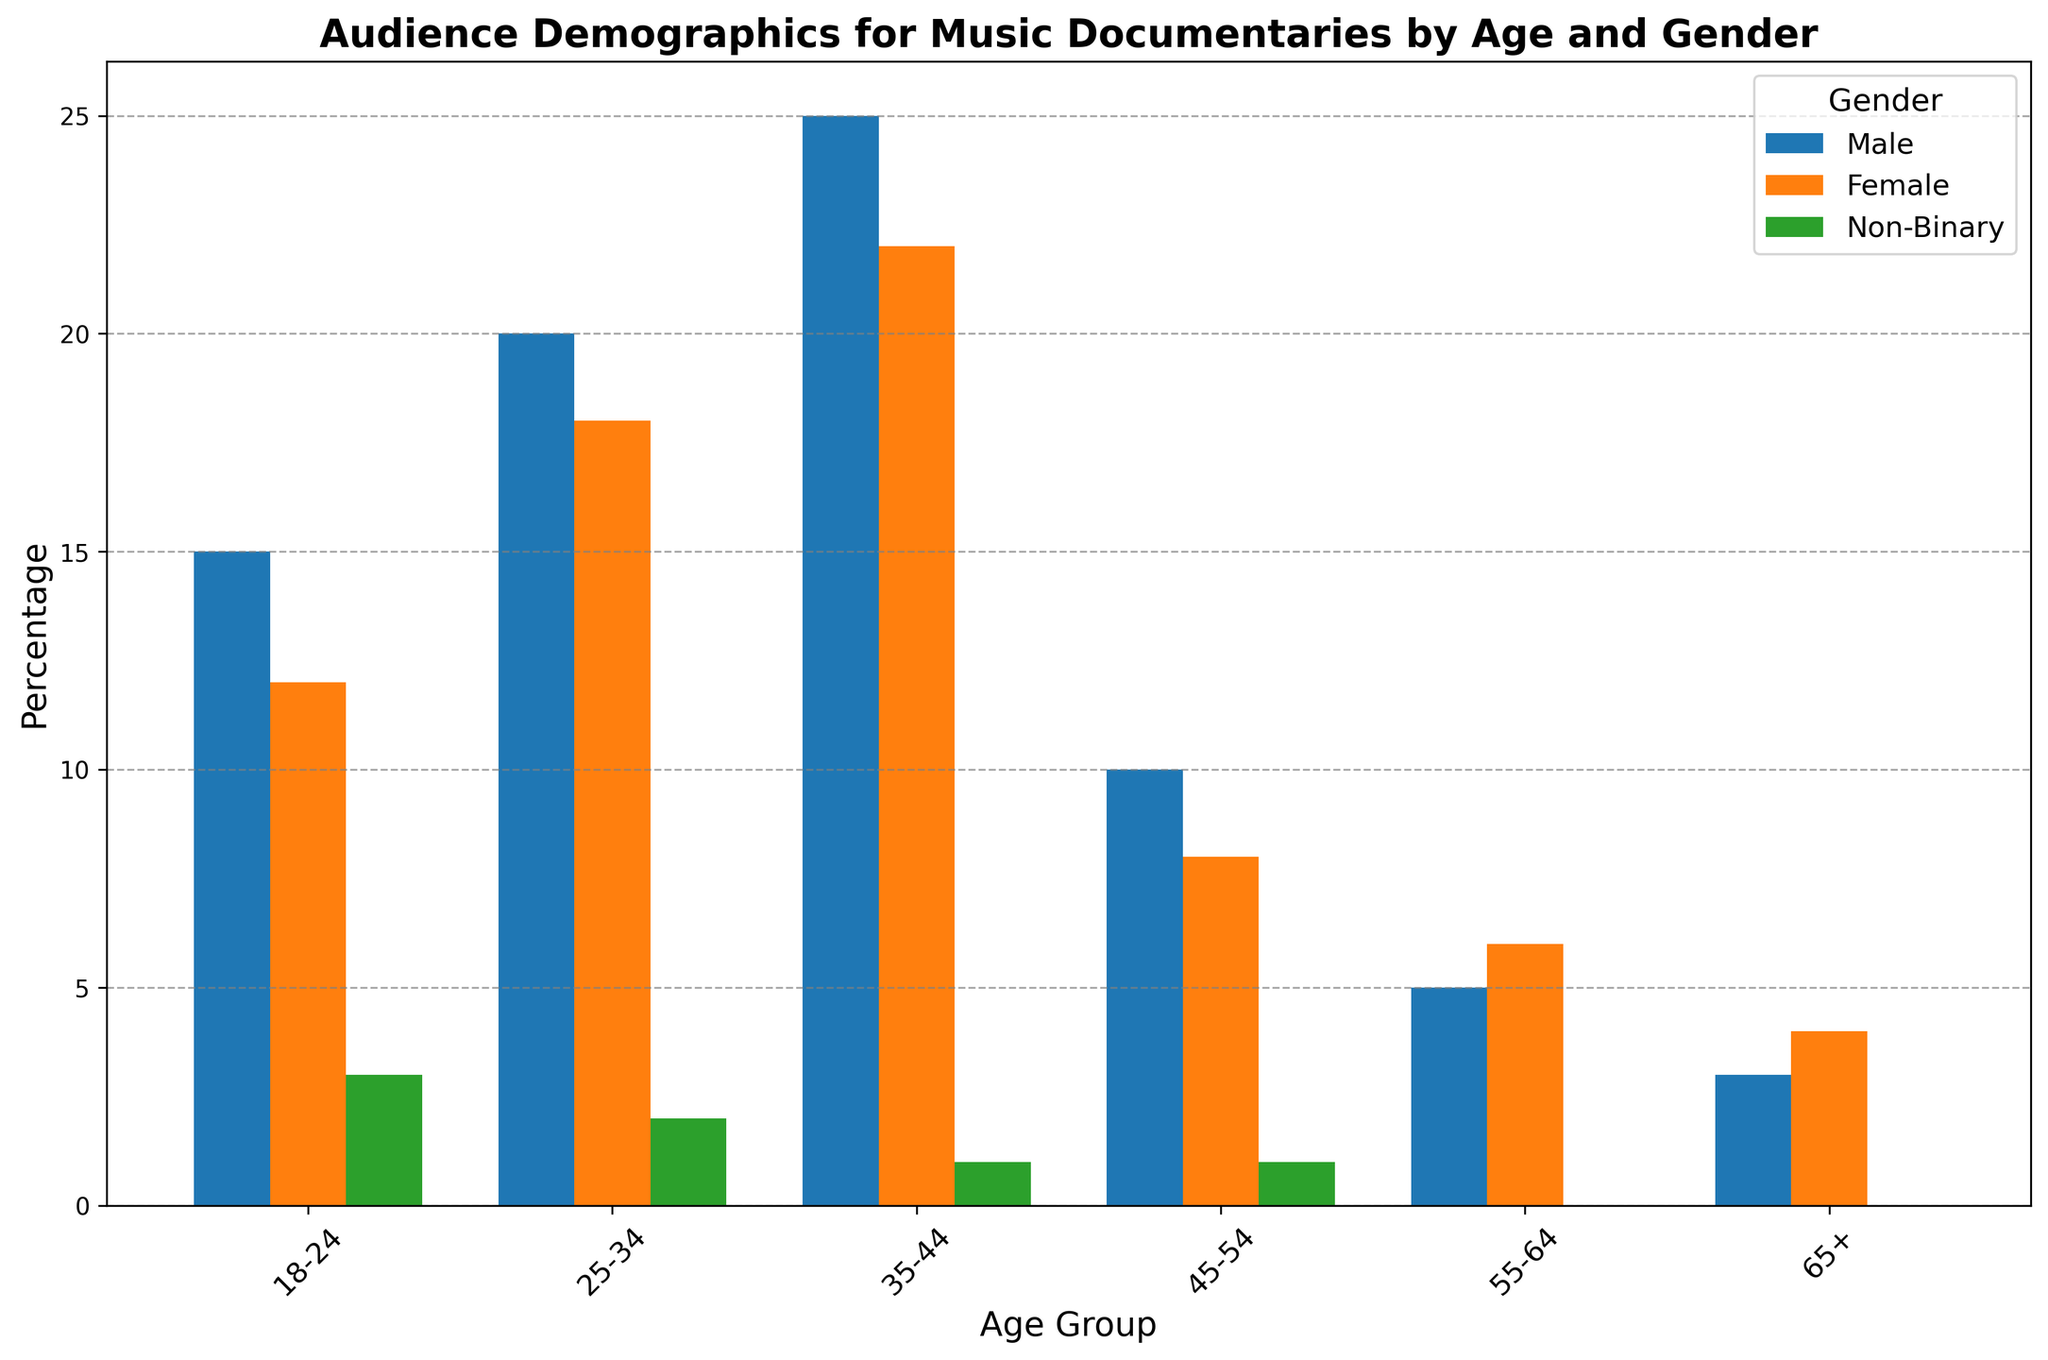Which gender has the highest percentage in the 35-44 age group? Look at the bars representing the 35-44 age group and compare the heights for each gender. The highest bar belongs to males.
Answer: Male What is the difference in percentage between males and females in the 25-34 age group? Find the heights of the bars for males and females in the 25-34 age group. Males have 20% and females have 18%. Subtract the female percentage from the male percentage: 20 - 18.
Answer: 2% Which age group has the lowest percentage of non-binary viewers? Look at all the bars representing non-binary viewers. The 55-64 and 65+ age groups both have the lowest bars, each showing 0%.
Answer: 55-64 and 65+ What is the total percentage of viewers aged 18-24? Sum the heights of the bars for males, females, and non-binary viewers in the 18-24 age group: 15 + 12 + 3.
Answer: 30% How many percentage points higher is the male percentage compared to the female percentage in the 35-44 age group? Compare the values for males and females in the 35-44 age group. Males have 25% and females have 22%. Subtract the female percentage from the male percentage: 25 - 22.
Answer: 3% In which age group do females have the highest percentage of viewers? Compare the heights of all the bars representing female viewers across different age groups. The highest bar for females is in the 35-44 age group.
Answer: 35-44 Is there an age group in which the percentage of non-binary viewers equals that of male viewers? Go through each age group and compare the heights of bars for non-binary and male viewers. There is no such age group where these percentages are equal.
Answer: No What is the average percentage of viewers for the age group 25-34 across all genders? Sum the heights of the bars for all genders in the 25-34 age group: 20 + 18 + 2. Then divide by the number of genders: (20 + 18 + 2) / 3.
Answer: 13.33% Which age group and gender combination has the second-highest percentage of viewers? Identify and rank the heights of all bars. The highest is 25% (males 35-44), and the second highest is 22% (females 35-44).
Answer: Females 35-44 